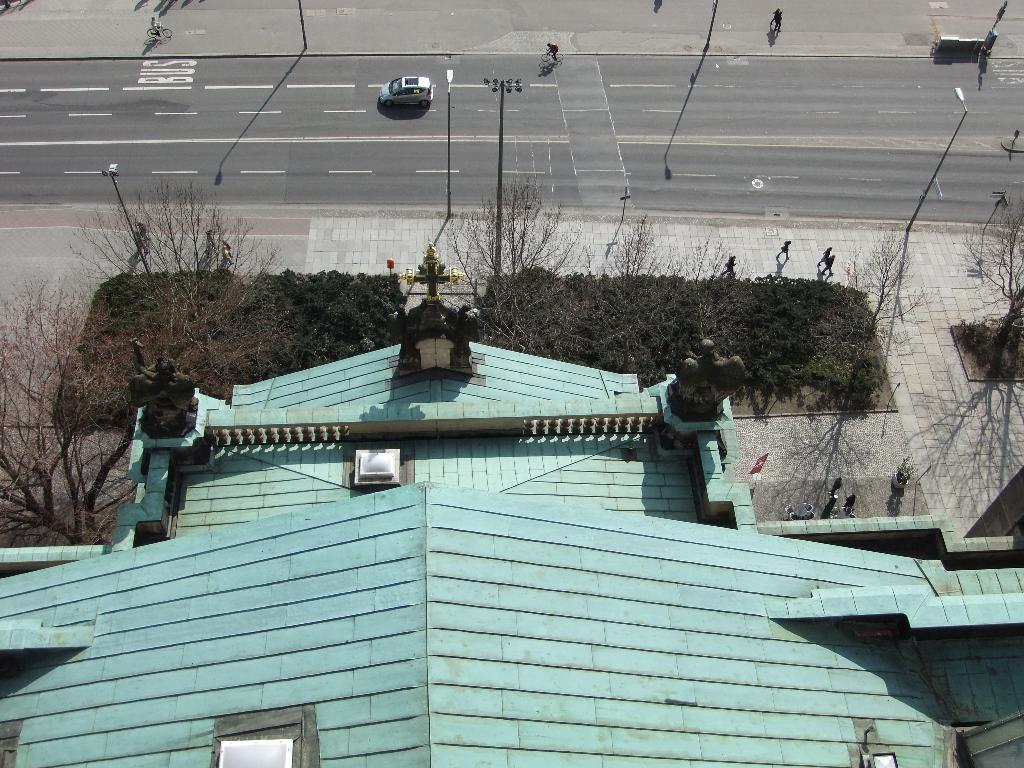What type of view is depicted in the image? The image shows an aerial view of a house. What is the color of the house in the image? The house is blue in color. What can be seen on the path near the house? There are plants and trees on the path near the house. What is located near the house? There is a road near the house. What is present on the road? There are vehicles on the road. Can you recall any specific memories associated with the house in the image? The image does not provide any information about specific memories associated with the house. What type of clouds can be seen in the image? There are no clouds visible in the image, as it is an aerial view of a house and its surroundings. 